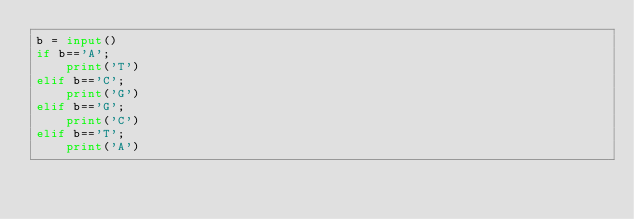Convert code to text. <code><loc_0><loc_0><loc_500><loc_500><_Python_>b = input()
if b=='A';
    print('T')
elif b=='C';
    print('G')
elif b=='G';
    print('C')
elif b=='T';
    print('A')</code> 